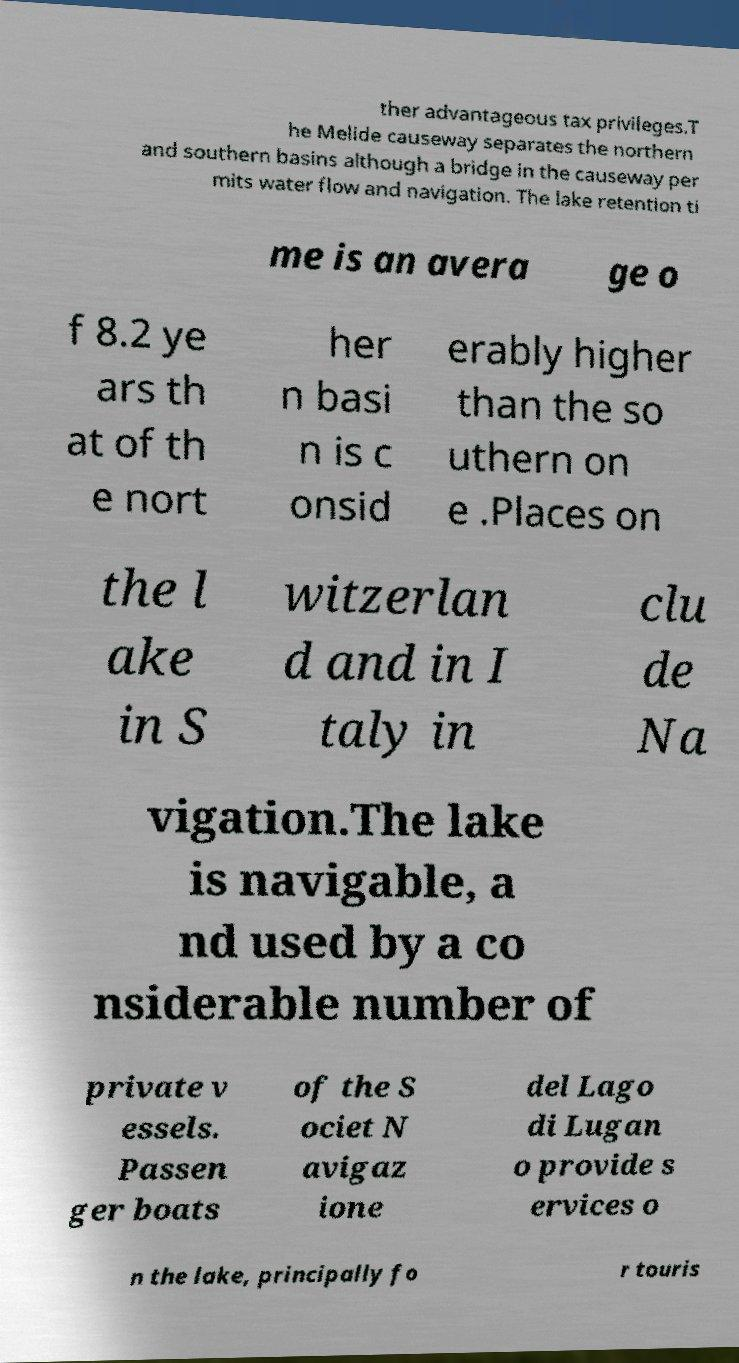I need the written content from this picture converted into text. Can you do that? ther advantageous tax privileges.T he Melide causeway separates the northern and southern basins although a bridge in the causeway per mits water flow and navigation. The lake retention ti me is an avera ge o f 8.2 ye ars th at of th e nort her n basi n is c onsid erably higher than the so uthern on e .Places on the l ake in S witzerlan d and in I taly in clu de Na vigation.The lake is navigable, a nd used by a co nsiderable number of private v essels. Passen ger boats of the S ociet N avigaz ione del Lago di Lugan o provide s ervices o n the lake, principally fo r touris 